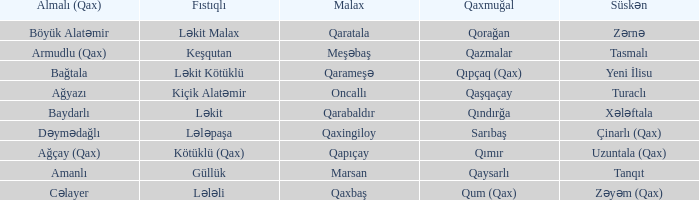What is the Almali village with the Süskən village zərnə? Böyük Alatəmir. 